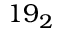Convert formula to latex. <formula><loc_0><loc_0><loc_500><loc_500>1 9 _ { 2 }</formula> 